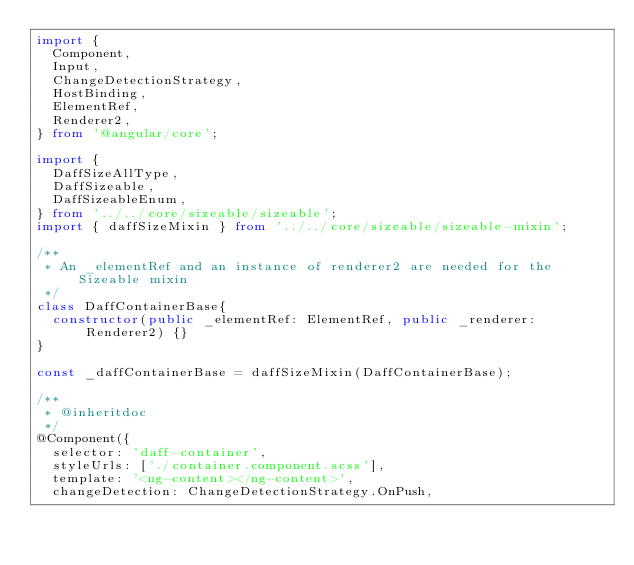<code> <loc_0><loc_0><loc_500><loc_500><_TypeScript_>import {
  Component,
  Input,
  ChangeDetectionStrategy,
  HostBinding,
  ElementRef,
  Renderer2,
} from '@angular/core';

import {
  DaffSizeAllType,
  DaffSizeable,
  DaffSizeableEnum,
} from '../../core/sizeable/sizeable';
import { daffSizeMixin } from '../../core/sizeable/sizeable-mixin';

/**
 * An _elementRef and an instance of renderer2 are needed for the Sizeable mixin
 */
class DaffContainerBase{
  constructor(public _elementRef: ElementRef, public _renderer: Renderer2) {}
}

const _daffContainerBase = daffSizeMixin(DaffContainerBase);

/**
 * @inheritdoc
 */
@Component({
  selector: 'daff-container',
  styleUrls: ['./container.component.scss'],
  template: '<ng-content></ng-content>',
  changeDetection: ChangeDetectionStrategy.OnPush,</code> 